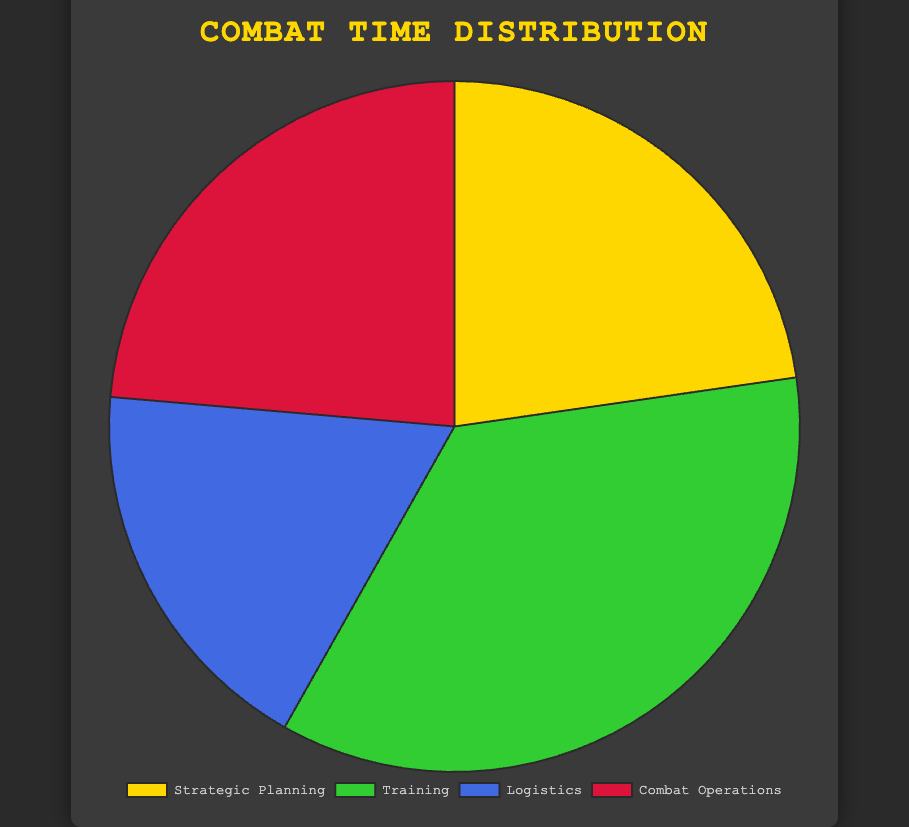What percentage of time is spent on strategic planning relative to training? The percentage of time spent on strategic planning is 25%, whereas training takes 39%. By comparing these values, strategic planning is 14% less than training.
Answer: 14% less Which activity group has the smallest allocation of time? Comparing the percentages: Strategic Planning (25%), Training (39%), Logistics (20%), and Combat Operations (26%), Logistics has the smallest allocation at 20%.
Answer: Logistics By how much does the combined time for operational planning and tactical drills differ from the combined time for direct engagements and supply chain management? Operational Planning (5%) + Tactical Drills (15%) = 20%. Direct Engagements (8%) + Supply Chain Management (6%) = 14%. The difference is 20% - 14% = 6%.
Answer: 6% Which two activities have a combined allocation of over 50%? Training (39%) combined with any other activity will exceed 50%. For instance, Training (39%) + Combat Operations (26%) = 65%.
Answer: Training and Combat Operations What is the average percentage of time spent on all activities in strategic planning combined? To find the average, sum the percentages: 10% (Initial Deployment) + 5% (Operational Planning) + 3% (After Action Review) + 7% (Intelligence Analysis) = 25%. The average is 25% / 4 = 6.25%.
Answer: 6.25% Which group requires the most time allocation, and by how much more than logistics? Training (39%) requires the most time allocation. Comparing this to Logistics (20%), it requires 39% - 20% = 19% more.
Answer: Training requires 19% more What proportion of the pie chart is covered by combat operations? Combat operations make up 26% of the total pie chart.
Answer: 26% Compare the total time allocation for physical fitness training and direct engagements. Physical Fitness Training is 6% and Direct Engagements is 8%. Combined, they sum up to 6% + 8% = 14%.
Answer: 14% What is the difference between the time spent on medical support and defense operations? Medical Support takes 4% of the time, whereas Defense Operations take 6%. The difference is 6% - 4% = 2%.
Answer: 2% If we seggregate activities into "pre-combat" (strategic planning, training) and "combat-related" (logistics, combat operations), what is the total time spent on each, and which is greater? Summing the pre-combat activities: Strategic Planning (25%) + Training (39%) = 64%. Summing combat-related activities: Logistics (20%) + Combat Operations (26%) = 46%. Therefore, 64% is greater than 46%.
Answer: Pre-combat at 64% 